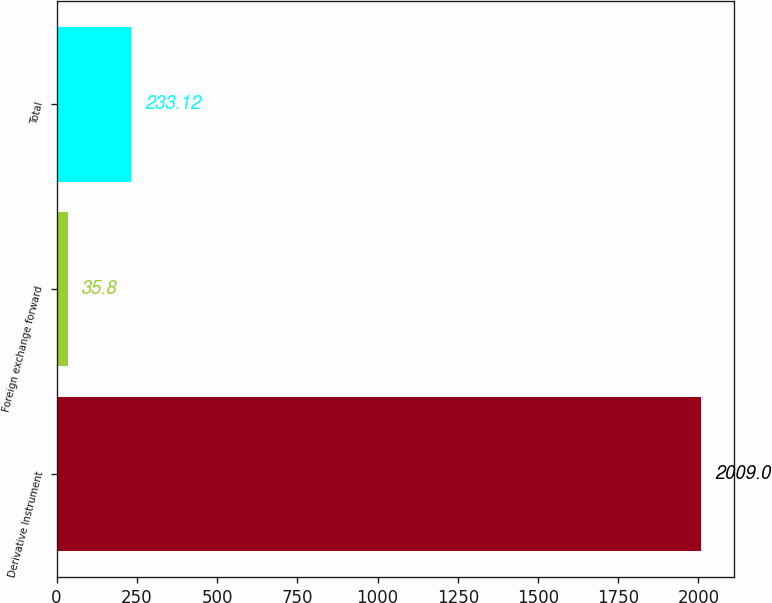<chart> <loc_0><loc_0><loc_500><loc_500><bar_chart><fcel>Derivative Instrument<fcel>Foreign exchange forward<fcel>Total<nl><fcel>2009<fcel>35.8<fcel>233.12<nl></chart> 